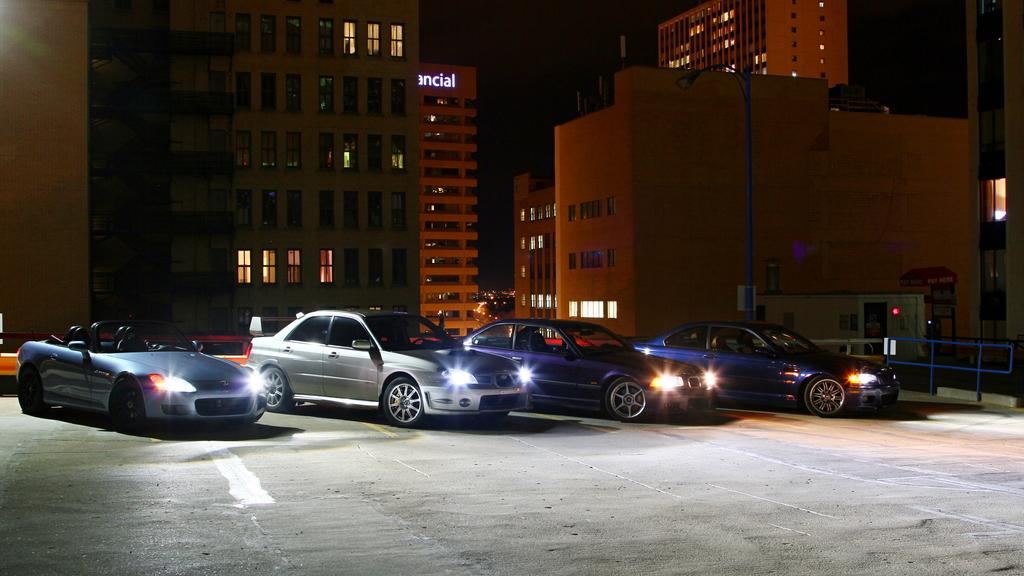What is located in the center of the image? There are buildings, vehicles, railing, poles, boards, and lights in the center of the image. What type of structures are present in the image? The buildings and railing suggest that there are some architectural structures in the image. What can be seen above the center of the image? The sky is visible at the top of the image. What is present at the bottom of the image? There is a walkway at the bottom of the image. Where is the stove located in the image? There is no stove present in the image. What type of can is visible in the image? There is no can present in the image. 